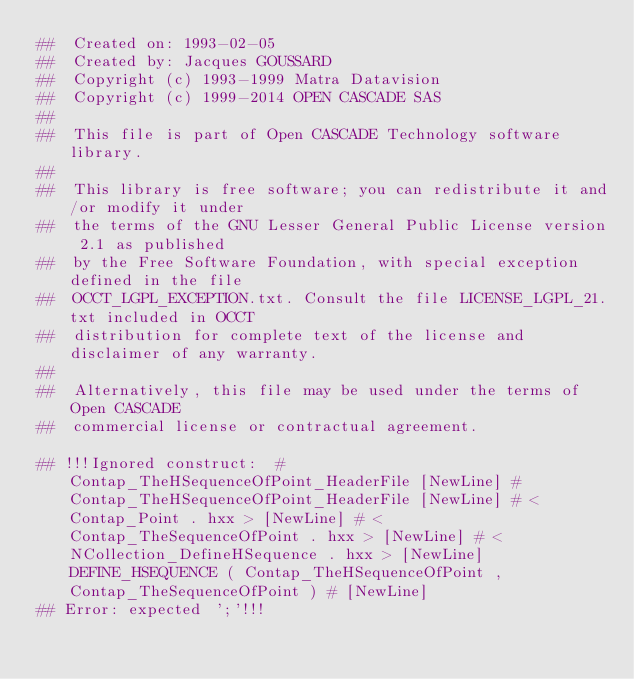Convert code to text. <code><loc_0><loc_0><loc_500><loc_500><_Nim_>##  Created on: 1993-02-05
##  Created by: Jacques GOUSSARD
##  Copyright (c) 1993-1999 Matra Datavision
##  Copyright (c) 1999-2014 OPEN CASCADE SAS
##
##  This file is part of Open CASCADE Technology software library.
##
##  This library is free software; you can redistribute it and/or modify it under
##  the terms of the GNU Lesser General Public License version 2.1 as published
##  by the Free Software Foundation, with special exception defined in the file
##  OCCT_LGPL_EXCEPTION.txt. Consult the file LICENSE_LGPL_21.txt included in OCCT
##  distribution for complete text of the license and disclaimer of any warranty.
##
##  Alternatively, this file may be used under the terms of Open CASCADE
##  commercial license or contractual agreement.

## !!!Ignored construct:  # Contap_TheHSequenceOfPoint_HeaderFile [NewLine] # Contap_TheHSequenceOfPoint_HeaderFile [NewLine] # < Contap_Point . hxx > [NewLine] # < Contap_TheSequenceOfPoint . hxx > [NewLine] # < NCollection_DefineHSequence . hxx > [NewLine] DEFINE_HSEQUENCE ( Contap_TheHSequenceOfPoint , Contap_TheSequenceOfPoint ) # [NewLine]
## Error: expected ';'!!!














































</code> 